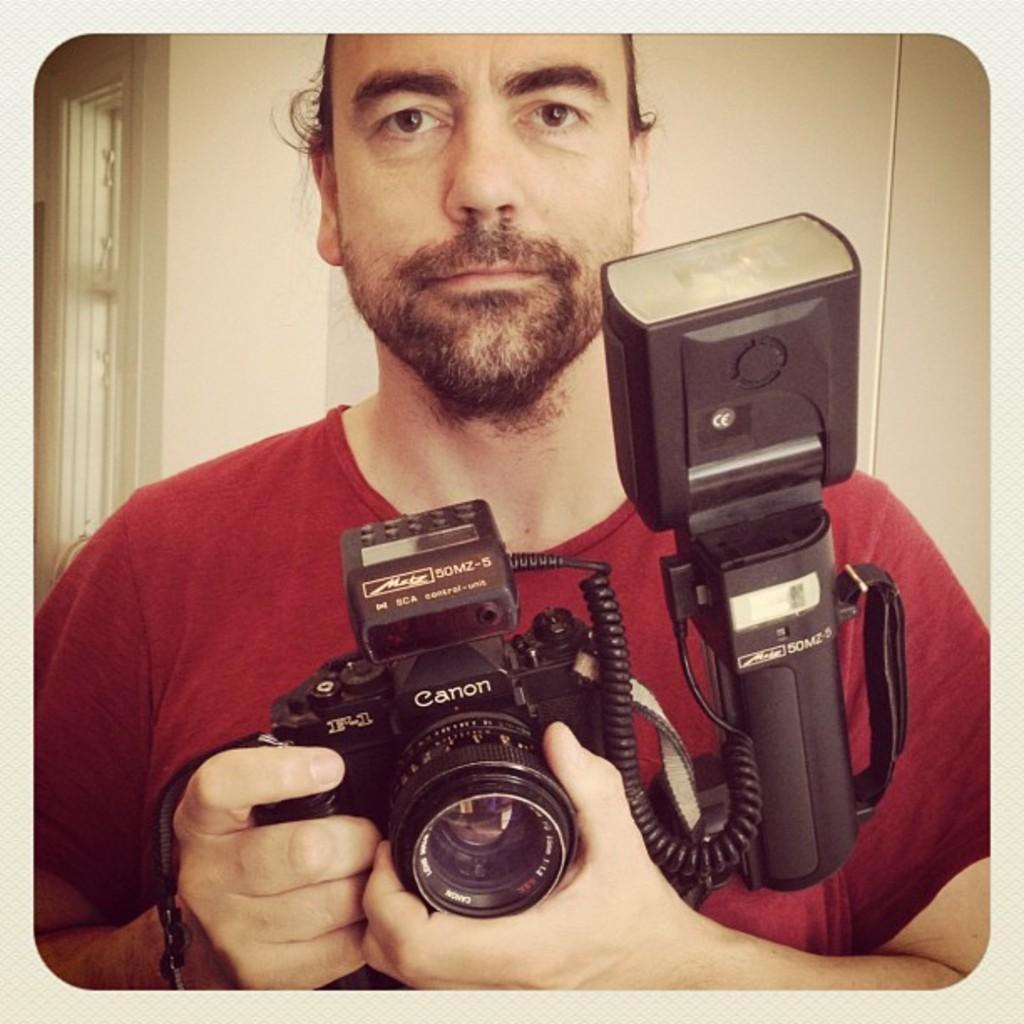Could you give a brief overview of what you see in this image? In the foreground, I can see a person is holding a camera in hand. In the background, I can see a wall and a window. This picture might be taken in a room. 